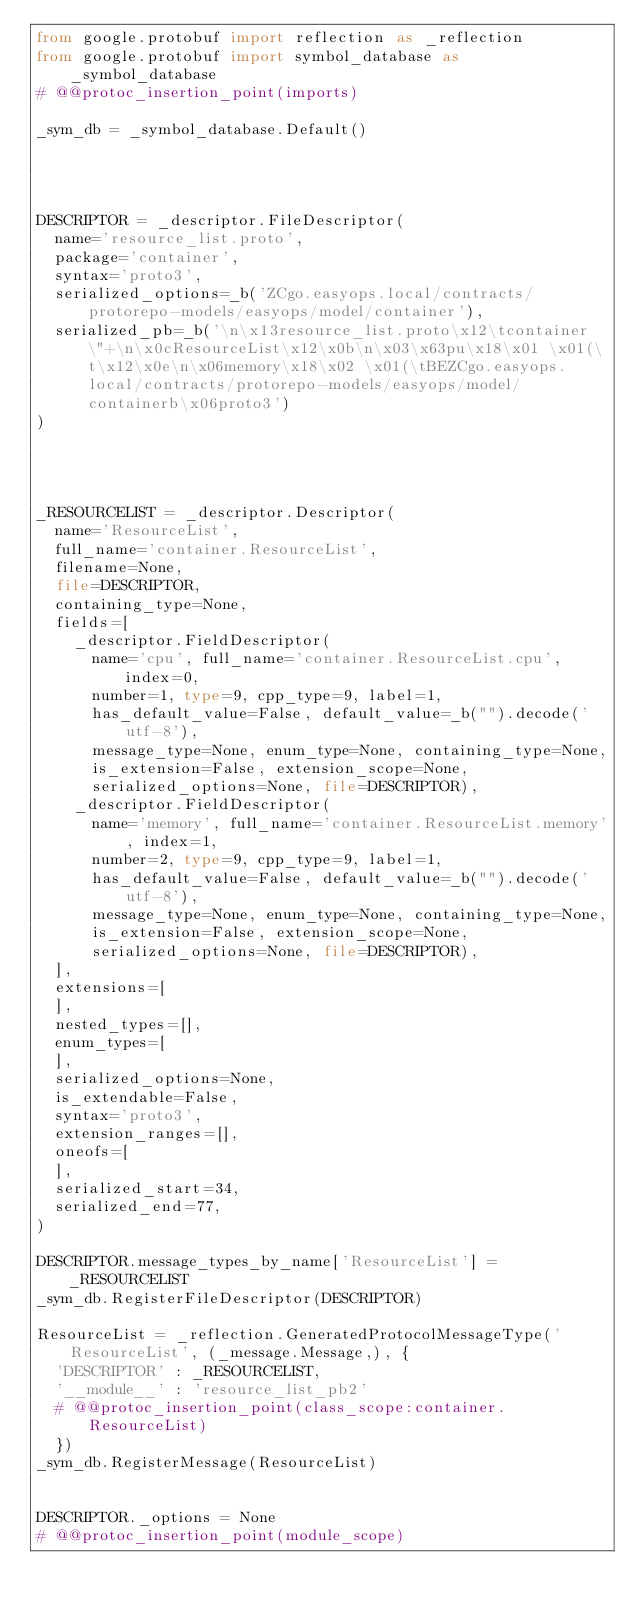Convert code to text. <code><loc_0><loc_0><loc_500><loc_500><_Python_>from google.protobuf import reflection as _reflection
from google.protobuf import symbol_database as _symbol_database
# @@protoc_insertion_point(imports)

_sym_db = _symbol_database.Default()




DESCRIPTOR = _descriptor.FileDescriptor(
  name='resource_list.proto',
  package='container',
  syntax='proto3',
  serialized_options=_b('ZCgo.easyops.local/contracts/protorepo-models/easyops/model/container'),
  serialized_pb=_b('\n\x13resource_list.proto\x12\tcontainer\"+\n\x0cResourceList\x12\x0b\n\x03\x63pu\x18\x01 \x01(\t\x12\x0e\n\x06memory\x18\x02 \x01(\tBEZCgo.easyops.local/contracts/protorepo-models/easyops/model/containerb\x06proto3')
)




_RESOURCELIST = _descriptor.Descriptor(
  name='ResourceList',
  full_name='container.ResourceList',
  filename=None,
  file=DESCRIPTOR,
  containing_type=None,
  fields=[
    _descriptor.FieldDescriptor(
      name='cpu', full_name='container.ResourceList.cpu', index=0,
      number=1, type=9, cpp_type=9, label=1,
      has_default_value=False, default_value=_b("").decode('utf-8'),
      message_type=None, enum_type=None, containing_type=None,
      is_extension=False, extension_scope=None,
      serialized_options=None, file=DESCRIPTOR),
    _descriptor.FieldDescriptor(
      name='memory', full_name='container.ResourceList.memory', index=1,
      number=2, type=9, cpp_type=9, label=1,
      has_default_value=False, default_value=_b("").decode('utf-8'),
      message_type=None, enum_type=None, containing_type=None,
      is_extension=False, extension_scope=None,
      serialized_options=None, file=DESCRIPTOR),
  ],
  extensions=[
  ],
  nested_types=[],
  enum_types=[
  ],
  serialized_options=None,
  is_extendable=False,
  syntax='proto3',
  extension_ranges=[],
  oneofs=[
  ],
  serialized_start=34,
  serialized_end=77,
)

DESCRIPTOR.message_types_by_name['ResourceList'] = _RESOURCELIST
_sym_db.RegisterFileDescriptor(DESCRIPTOR)

ResourceList = _reflection.GeneratedProtocolMessageType('ResourceList', (_message.Message,), {
  'DESCRIPTOR' : _RESOURCELIST,
  '__module__' : 'resource_list_pb2'
  # @@protoc_insertion_point(class_scope:container.ResourceList)
  })
_sym_db.RegisterMessage(ResourceList)


DESCRIPTOR._options = None
# @@protoc_insertion_point(module_scope)
</code> 